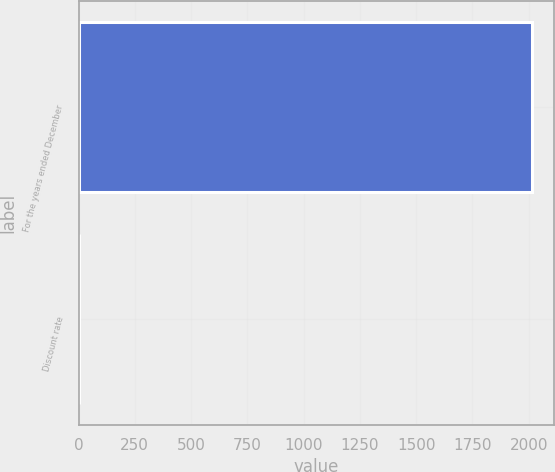Convert chart to OTSL. <chart><loc_0><loc_0><loc_500><loc_500><bar_chart><fcel>For the years ended December<fcel>Discount rate<nl><fcel>2013<fcel>3.7<nl></chart> 